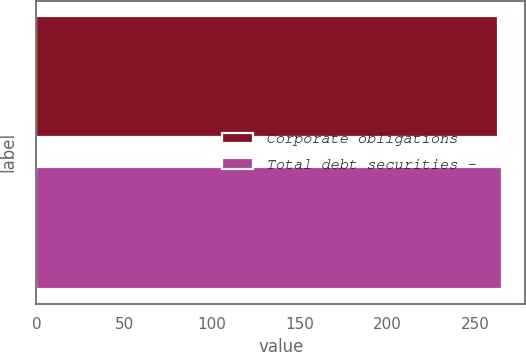Convert chart. <chart><loc_0><loc_0><loc_500><loc_500><bar_chart><fcel>Corporate obligations<fcel>Total debt securities -<nl><fcel>263<fcel>265<nl></chart> 